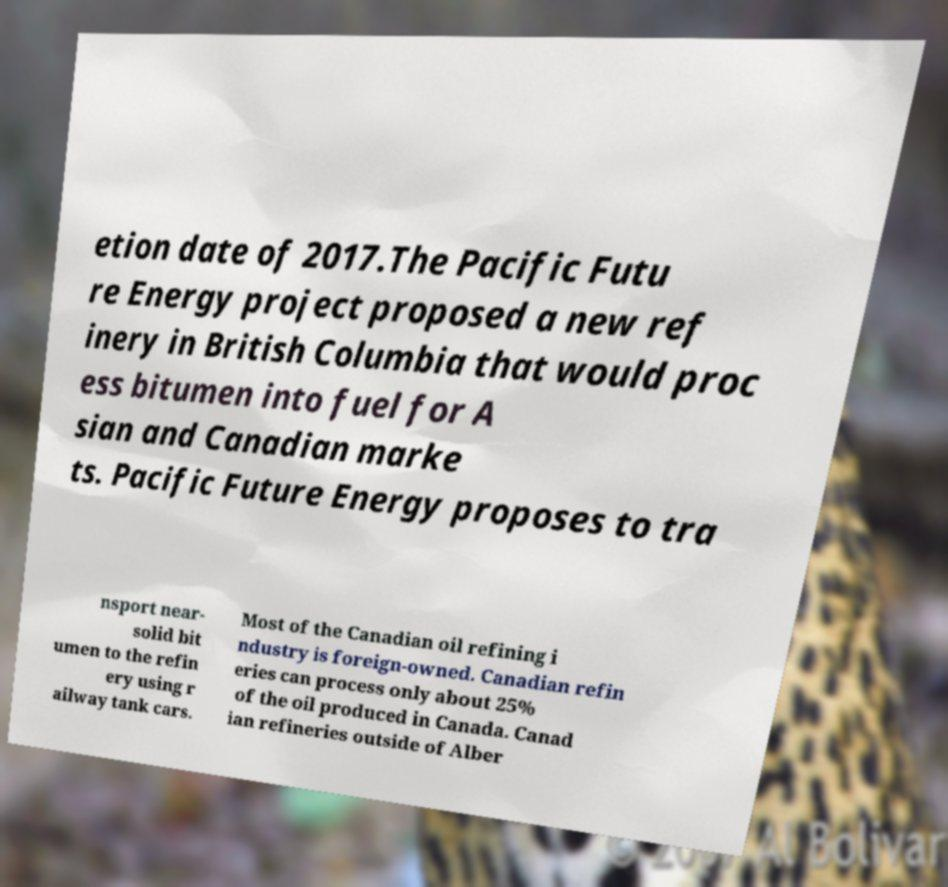For documentation purposes, I need the text within this image transcribed. Could you provide that? etion date of 2017.The Pacific Futu re Energy project proposed a new ref inery in British Columbia that would proc ess bitumen into fuel for A sian and Canadian marke ts. Pacific Future Energy proposes to tra nsport near- solid bit umen to the refin ery using r ailway tank cars. Most of the Canadian oil refining i ndustry is foreign-owned. Canadian refin eries can process only about 25% of the oil produced in Canada. Canad ian refineries outside of Alber 